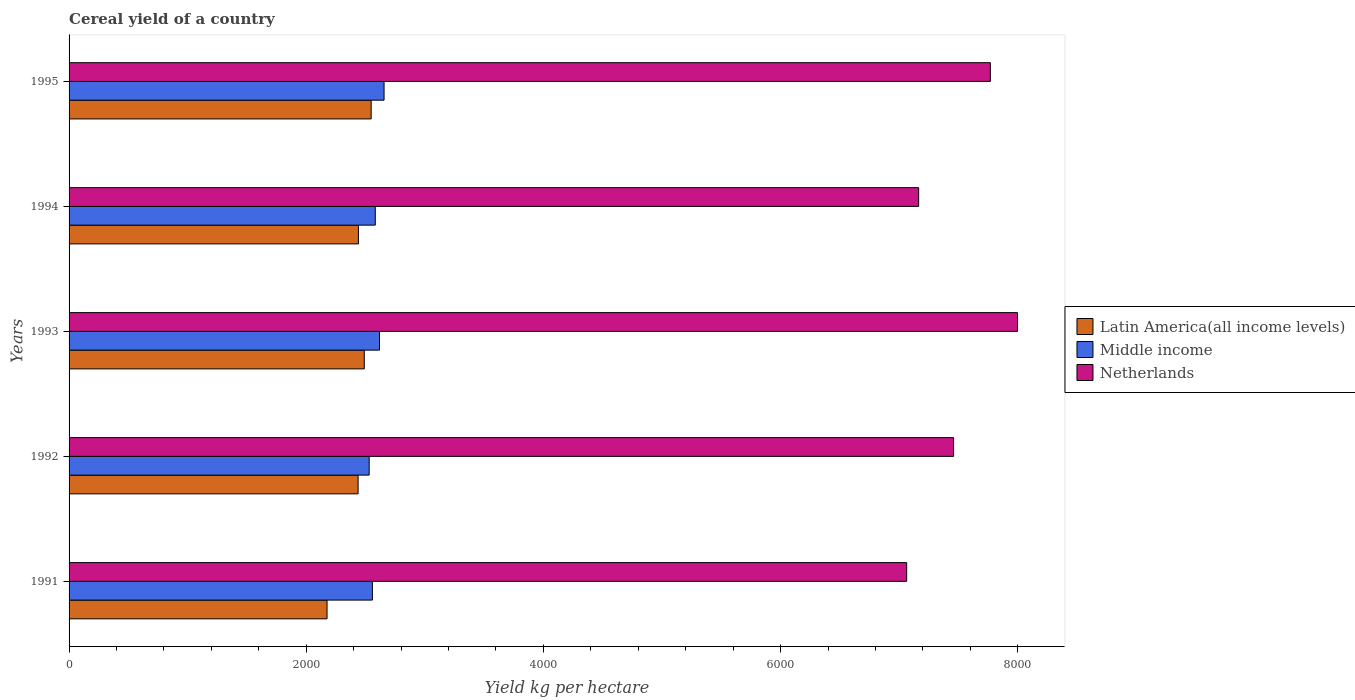How many different coloured bars are there?
Your answer should be compact. 3. How many groups of bars are there?
Offer a terse response. 5. Are the number of bars per tick equal to the number of legend labels?
Give a very brief answer. Yes. Are the number of bars on each tick of the Y-axis equal?
Keep it short and to the point. Yes. What is the total cereal yield in Middle income in 1995?
Provide a succinct answer. 2656.31. Across all years, what is the maximum total cereal yield in Middle income?
Ensure brevity in your answer.  2656.31. Across all years, what is the minimum total cereal yield in Latin America(all income levels)?
Your answer should be very brief. 2175.5. In which year was the total cereal yield in Netherlands maximum?
Offer a very short reply. 1993. What is the total total cereal yield in Latin America(all income levels) in the graph?
Give a very brief answer. 1.21e+04. What is the difference between the total cereal yield in Latin America(all income levels) in 1992 and that in 1994?
Offer a terse response. -2.81. What is the difference between the total cereal yield in Middle income in 1994 and the total cereal yield in Netherlands in 1991?
Make the answer very short. -4481.18. What is the average total cereal yield in Middle income per year?
Provide a succinct answer. 2588.96. In the year 1995, what is the difference between the total cereal yield in Netherlands and total cereal yield in Latin America(all income levels)?
Offer a terse response. 5221.77. What is the ratio of the total cereal yield in Middle income in 1991 to that in 1992?
Your answer should be compact. 1.01. Is the difference between the total cereal yield in Netherlands in 1994 and 1995 greater than the difference between the total cereal yield in Latin America(all income levels) in 1994 and 1995?
Ensure brevity in your answer.  No. What is the difference between the highest and the second highest total cereal yield in Latin America(all income levels)?
Give a very brief answer. 57.98. What is the difference between the highest and the lowest total cereal yield in Middle income?
Ensure brevity in your answer.  125.56. In how many years, is the total cereal yield in Middle income greater than the average total cereal yield in Middle income taken over all years?
Give a very brief answer. 2. What does the 3rd bar from the top in 1993 represents?
Offer a terse response. Latin America(all income levels). What does the 1st bar from the bottom in 1992 represents?
Your response must be concise. Latin America(all income levels). How many bars are there?
Your answer should be compact. 15. Are the values on the major ticks of X-axis written in scientific E-notation?
Ensure brevity in your answer.  No. How many legend labels are there?
Your answer should be compact. 3. How are the legend labels stacked?
Make the answer very short. Vertical. What is the title of the graph?
Give a very brief answer. Cereal yield of a country. Does "French Polynesia" appear as one of the legend labels in the graph?
Provide a short and direct response. No. What is the label or title of the X-axis?
Offer a terse response. Yield kg per hectare. What is the label or title of the Y-axis?
Your response must be concise. Years. What is the Yield kg per hectare in Latin America(all income levels) in 1991?
Offer a terse response. 2175.5. What is the Yield kg per hectare of Middle income in 1991?
Provide a short and direct response. 2557.74. What is the Yield kg per hectare in Netherlands in 1991?
Offer a very short reply. 7063.39. What is the Yield kg per hectare of Latin America(all income levels) in 1992?
Provide a succinct answer. 2437.3. What is the Yield kg per hectare in Middle income in 1992?
Make the answer very short. 2530.75. What is the Yield kg per hectare of Netherlands in 1992?
Keep it short and to the point. 7459.23. What is the Yield kg per hectare in Latin America(all income levels) in 1993?
Give a very brief answer. 2489.49. What is the Yield kg per hectare of Middle income in 1993?
Your answer should be very brief. 2617.8. What is the Yield kg per hectare of Netherlands in 1993?
Provide a short and direct response. 7998.36. What is the Yield kg per hectare of Latin America(all income levels) in 1994?
Offer a terse response. 2440.11. What is the Yield kg per hectare of Middle income in 1994?
Ensure brevity in your answer.  2582.21. What is the Yield kg per hectare of Netherlands in 1994?
Make the answer very short. 7164.46. What is the Yield kg per hectare in Latin America(all income levels) in 1995?
Offer a very short reply. 2547.46. What is the Yield kg per hectare in Middle income in 1995?
Offer a very short reply. 2656.31. What is the Yield kg per hectare of Netherlands in 1995?
Ensure brevity in your answer.  7769.23. Across all years, what is the maximum Yield kg per hectare in Latin America(all income levels)?
Offer a terse response. 2547.46. Across all years, what is the maximum Yield kg per hectare of Middle income?
Offer a very short reply. 2656.31. Across all years, what is the maximum Yield kg per hectare of Netherlands?
Offer a very short reply. 7998.36. Across all years, what is the minimum Yield kg per hectare in Latin America(all income levels)?
Offer a terse response. 2175.5. Across all years, what is the minimum Yield kg per hectare in Middle income?
Keep it short and to the point. 2530.75. Across all years, what is the minimum Yield kg per hectare in Netherlands?
Your answer should be very brief. 7063.39. What is the total Yield kg per hectare of Latin America(all income levels) in the graph?
Your answer should be very brief. 1.21e+04. What is the total Yield kg per hectare of Middle income in the graph?
Offer a terse response. 1.29e+04. What is the total Yield kg per hectare in Netherlands in the graph?
Keep it short and to the point. 3.75e+04. What is the difference between the Yield kg per hectare in Latin America(all income levels) in 1991 and that in 1992?
Your answer should be very brief. -261.8. What is the difference between the Yield kg per hectare in Middle income in 1991 and that in 1992?
Your response must be concise. 26.99. What is the difference between the Yield kg per hectare in Netherlands in 1991 and that in 1992?
Offer a terse response. -395.84. What is the difference between the Yield kg per hectare of Latin America(all income levels) in 1991 and that in 1993?
Your answer should be compact. -313.99. What is the difference between the Yield kg per hectare of Middle income in 1991 and that in 1993?
Give a very brief answer. -60.06. What is the difference between the Yield kg per hectare in Netherlands in 1991 and that in 1993?
Provide a short and direct response. -934.97. What is the difference between the Yield kg per hectare in Latin America(all income levels) in 1991 and that in 1994?
Your answer should be compact. -264.61. What is the difference between the Yield kg per hectare in Middle income in 1991 and that in 1994?
Your answer should be very brief. -24.46. What is the difference between the Yield kg per hectare in Netherlands in 1991 and that in 1994?
Keep it short and to the point. -101.07. What is the difference between the Yield kg per hectare in Latin America(all income levels) in 1991 and that in 1995?
Ensure brevity in your answer.  -371.96. What is the difference between the Yield kg per hectare of Middle income in 1991 and that in 1995?
Your answer should be very brief. -98.57. What is the difference between the Yield kg per hectare in Netherlands in 1991 and that in 1995?
Your answer should be compact. -705.84. What is the difference between the Yield kg per hectare in Latin America(all income levels) in 1992 and that in 1993?
Offer a terse response. -52.19. What is the difference between the Yield kg per hectare of Middle income in 1992 and that in 1993?
Give a very brief answer. -87.05. What is the difference between the Yield kg per hectare of Netherlands in 1992 and that in 1993?
Your answer should be very brief. -539.13. What is the difference between the Yield kg per hectare in Latin America(all income levels) in 1992 and that in 1994?
Offer a terse response. -2.81. What is the difference between the Yield kg per hectare of Middle income in 1992 and that in 1994?
Make the answer very short. -51.45. What is the difference between the Yield kg per hectare of Netherlands in 1992 and that in 1994?
Your response must be concise. 294.77. What is the difference between the Yield kg per hectare of Latin America(all income levels) in 1992 and that in 1995?
Your response must be concise. -110.16. What is the difference between the Yield kg per hectare of Middle income in 1992 and that in 1995?
Your answer should be compact. -125.56. What is the difference between the Yield kg per hectare in Netherlands in 1992 and that in 1995?
Offer a terse response. -310. What is the difference between the Yield kg per hectare of Latin America(all income levels) in 1993 and that in 1994?
Give a very brief answer. 49.37. What is the difference between the Yield kg per hectare of Middle income in 1993 and that in 1994?
Your answer should be compact. 35.6. What is the difference between the Yield kg per hectare in Netherlands in 1993 and that in 1994?
Ensure brevity in your answer.  833.9. What is the difference between the Yield kg per hectare in Latin America(all income levels) in 1993 and that in 1995?
Ensure brevity in your answer.  -57.98. What is the difference between the Yield kg per hectare of Middle income in 1993 and that in 1995?
Offer a terse response. -38.51. What is the difference between the Yield kg per hectare in Netherlands in 1993 and that in 1995?
Your answer should be compact. 229.13. What is the difference between the Yield kg per hectare of Latin America(all income levels) in 1994 and that in 1995?
Offer a very short reply. -107.35. What is the difference between the Yield kg per hectare in Middle income in 1994 and that in 1995?
Keep it short and to the point. -74.11. What is the difference between the Yield kg per hectare in Netherlands in 1994 and that in 1995?
Your answer should be compact. -604.77. What is the difference between the Yield kg per hectare of Latin America(all income levels) in 1991 and the Yield kg per hectare of Middle income in 1992?
Ensure brevity in your answer.  -355.25. What is the difference between the Yield kg per hectare of Latin America(all income levels) in 1991 and the Yield kg per hectare of Netherlands in 1992?
Your answer should be very brief. -5283.73. What is the difference between the Yield kg per hectare of Middle income in 1991 and the Yield kg per hectare of Netherlands in 1992?
Keep it short and to the point. -4901.48. What is the difference between the Yield kg per hectare in Latin America(all income levels) in 1991 and the Yield kg per hectare in Middle income in 1993?
Your answer should be compact. -442.3. What is the difference between the Yield kg per hectare in Latin America(all income levels) in 1991 and the Yield kg per hectare in Netherlands in 1993?
Offer a terse response. -5822.86. What is the difference between the Yield kg per hectare of Middle income in 1991 and the Yield kg per hectare of Netherlands in 1993?
Make the answer very short. -5440.62. What is the difference between the Yield kg per hectare in Latin America(all income levels) in 1991 and the Yield kg per hectare in Middle income in 1994?
Offer a very short reply. -406.7. What is the difference between the Yield kg per hectare in Latin America(all income levels) in 1991 and the Yield kg per hectare in Netherlands in 1994?
Provide a short and direct response. -4988.96. What is the difference between the Yield kg per hectare in Middle income in 1991 and the Yield kg per hectare in Netherlands in 1994?
Your response must be concise. -4606.72. What is the difference between the Yield kg per hectare in Latin America(all income levels) in 1991 and the Yield kg per hectare in Middle income in 1995?
Your answer should be compact. -480.81. What is the difference between the Yield kg per hectare in Latin America(all income levels) in 1991 and the Yield kg per hectare in Netherlands in 1995?
Offer a very short reply. -5593.73. What is the difference between the Yield kg per hectare in Middle income in 1991 and the Yield kg per hectare in Netherlands in 1995?
Keep it short and to the point. -5211.49. What is the difference between the Yield kg per hectare of Latin America(all income levels) in 1992 and the Yield kg per hectare of Middle income in 1993?
Give a very brief answer. -180.5. What is the difference between the Yield kg per hectare of Latin America(all income levels) in 1992 and the Yield kg per hectare of Netherlands in 1993?
Keep it short and to the point. -5561.06. What is the difference between the Yield kg per hectare of Middle income in 1992 and the Yield kg per hectare of Netherlands in 1993?
Your response must be concise. -5467.61. What is the difference between the Yield kg per hectare in Latin America(all income levels) in 1992 and the Yield kg per hectare in Middle income in 1994?
Your answer should be very brief. -144.9. What is the difference between the Yield kg per hectare of Latin America(all income levels) in 1992 and the Yield kg per hectare of Netherlands in 1994?
Make the answer very short. -4727.16. What is the difference between the Yield kg per hectare of Middle income in 1992 and the Yield kg per hectare of Netherlands in 1994?
Offer a terse response. -4633.71. What is the difference between the Yield kg per hectare of Latin America(all income levels) in 1992 and the Yield kg per hectare of Middle income in 1995?
Provide a succinct answer. -219.01. What is the difference between the Yield kg per hectare of Latin America(all income levels) in 1992 and the Yield kg per hectare of Netherlands in 1995?
Ensure brevity in your answer.  -5331.93. What is the difference between the Yield kg per hectare in Middle income in 1992 and the Yield kg per hectare in Netherlands in 1995?
Provide a succinct answer. -5238.48. What is the difference between the Yield kg per hectare in Latin America(all income levels) in 1993 and the Yield kg per hectare in Middle income in 1994?
Offer a terse response. -92.72. What is the difference between the Yield kg per hectare in Latin America(all income levels) in 1993 and the Yield kg per hectare in Netherlands in 1994?
Keep it short and to the point. -4674.98. What is the difference between the Yield kg per hectare of Middle income in 1993 and the Yield kg per hectare of Netherlands in 1994?
Offer a very short reply. -4546.66. What is the difference between the Yield kg per hectare of Latin America(all income levels) in 1993 and the Yield kg per hectare of Middle income in 1995?
Offer a terse response. -166.83. What is the difference between the Yield kg per hectare of Latin America(all income levels) in 1993 and the Yield kg per hectare of Netherlands in 1995?
Offer a terse response. -5279.74. What is the difference between the Yield kg per hectare of Middle income in 1993 and the Yield kg per hectare of Netherlands in 1995?
Give a very brief answer. -5151.43. What is the difference between the Yield kg per hectare in Latin America(all income levels) in 1994 and the Yield kg per hectare in Middle income in 1995?
Provide a succinct answer. -216.2. What is the difference between the Yield kg per hectare in Latin America(all income levels) in 1994 and the Yield kg per hectare in Netherlands in 1995?
Give a very brief answer. -5329.12. What is the difference between the Yield kg per hectare of Middle income in 1994 and the Yield kg per hectare of Netherlands in 1995?
Give a very brief answer. -5187.03. What is the average Yield kg per hectare in Latin America(all income levels) per year?
Give a very brief answer. 2417.97. What is the average Yield kg per hectare in Middle income per year?
Provide a succinct answer. 2588.96. What is the average Yield kg per hectare in Netherlands per year?
Your answer should be compact. 7490.94. In the year 1991, what is the difference between the Yield kg per hectare of Latin America(all income levels) and Yield kg per hectare of Middle income?
Offer a very short reply. -382.24. In the year 1991, what is the difference between the Yield kg per hectare of Latin America(all income levels) and Yield kg per hectare of Netherlands?
Your answer should be very brief. -4887.89. In the year 1991, what is the difference between the Yield kg per hectare in Middle income and Yield kg per hectare in Netherlands?
Provide a short and direct response. -4505.65. In the year 1992, what is the difference between the Yield kg per hectare of Latin America(all income levels) and Yield kg per hectare of Middle income?
Provide a succinct answer. -93.45. In the year 1992, what is the difference between the Yield kg per hectare in Latin America(all income levels) and Yield kg per hectare in Netherlands?
Provide a succinct answer. -5021.93. In the year 1992, what is the difference between the Yield kg per hectare of Middle income and Yield kg per hectare of Netherlands?
Your answer should be very brief. -4928.48. In the year 1993, what is the difference between the Yield kg per hectare in Latin America(all income levels) and Yield kg per hectare in Middle income?
Offer a very short reply. -128.32. In the year 1993, what is the difference between the Yield kg per hectare of Latin America(all income levels) and Yield kg per hectare of Netherlands?
Offer a terse response. -5508.88. In the year 1993, what is the difference between the Yield kg per hectare in Middle income and Yield kg per hectare in Netherlands?
Offer a very short reply. -5380.56. In the year 1994, what is the difference between the Yield kg per hectare in Latin America(all income levels) and Yield kg per hectare in Middle income?
Give a very brief answer. -142.09. In the year 1994, what is the difference between the Yield kg per hectare of Latin America(all income levels) and Yield kg per hectare of Netherlands?
Offer a terse response. -4724.35. In the year 1994, what is the difference between the Yield kg per hectare of Middle income and Yield kg per hectare of Netherlands?
Give a very brief answer. -4582.26. In the year 1995, what is the difference between the Yield kg per hectare in Latin America(all income levels) and Yield kg per hectare in Middle income?
Offer a terse response. -108.85. In the year 1995, what is the difference between the Yield kg per hectare in Latin America(all income levels) and Yield kg per hectare in Netherlands?
Your response must be concise. -5221.77. In the year 1995, what is the difference between the Yield kg per hectare of Middle income and Yield kg per hectare of Netherlands?
Offer a terse response. -5112.92. What is the ratio of the Yield kg per hectare of Latin America(all income levels) in 1991 to that in 1992?
Offer a terse response. 0.89. What is the ratio of the Yield kg per hectare in Middle income in 1991 to that in 1992?
Your answer should be very brief. 1.01. What is the ratio of the Yield kg per hectare in Netherlands in 1991 to that in 1992?
Offer a terse response. 0.95. What is the ratio of the Yield kg per hectare of Latin America(all income levels) in 1991 to that in 1993?
Provide a short and direct response. 0.87. What is the ratio of the Yield kg per hectare of Middle income in 1991 to that in 1993?
Offer a very short reply. 0.98. What is the ratio of the Yield kg per hectare in Netherlands in 1991 to that in 1993?
Ensure brevity in your answer.  0.88. What is the ratio of the Yield kg per hectare in Latin America(all income levels) in 1991 to that in 1994?
Provide a succinct answer. 0.89. What is the ratio of the Yield kg per hectare in Middle income in 1991 to that in 1994?
Give a very brief answer. 0.99. What is the ratio of the Yield kg per hectare of Netherlands in 1991 to that in 1994?
Keep it short and to the point. 0.99. What is the ratio of the Yield kg per hectare of Latin America(all income levels) in 1991 to that in 1995?
Provide a succinct answer. 0.85. What is the ratio of the Yield kg per hectare of Middle income in 1991 to that in 1995?
Make the answer very short. 0.96. What is the ratio of the Yield kg per hectare of Latin America(all income levels) in 1992 to that in 1993?
Provide a short and direct response. 0.98. What is the ratio of the Yield kg per hectare of Middle income in 1992 to that in 1993?
Make the answer very short. 0.97. What is the ratio of the Yield kg per hectare in Netherlands in 1992 to that in 1993?
Keep it short and to the point. 0.93. What is the ratio of the Yield kg per hectare in Middle income in 1992 to that in 1994?
Your answer should be very brief. 0.98. What is the ratio of the Yield kg per hectare of Netherlands in 1992 to that in 1994?
Give a very brief answer. 1.04. What is the ratio of the Yield kg per hectare of Latin America(all income levels) in 1992 to that in 1995?
Your response must be concise. 0.96. What is the ratio of the Yield kg per hectare in Middle income in 1992 to that in 1995?
Ensure brevity in your answer.  0.95. What is the ratio of the Yield kg per hectare of Netherlands in 1992 to that in 1995?
Make the answer very short. 0.96. What is the ratio of the Yield kg per hectare of Latin America(all income levels) in 1993 to that in 1994?
Keep it short and to the point. 1.02. What is the ratio of the Yield kg per hectare in Middle income in 1993 to that in 1994?
Offer a terse response. 1.01. What is the ratio of the Yield kg per hectare of Netherlands in 1993 to that in 1994?
Give a very brief answer. 1.12. What is the ratio of the Yield kg per hectare in Latin America(all income levels) in 1993 to that in 1995?
Your answer should be compact. 0.98. What is the ratio of the Yield kg per hectare in Middle income in 1993 to that in 1995?
Provide a short and direct response. 0.99. What is the ratio of the Yield kg per hectare in Netherlands in 1993 to that in 1995?
Provide a short and direct response. 1.03. What is the ratio of the Yield kg per hectare in Latin America(all income levels) in 1994 to that in 1995?
Offer a very short reply. 0.96. What is the ratio of the Yield kg per hectare of Middle income in 1994 to that in 1995?
Your response must be concise. 0.97. What is the ratio of the Yield kg per hectare of Netherlands in 1994 to that in 1995?
Your answer should be very brief. 0.92. What is the difference between the highest and the second highest Yield kg per hectare in Latin America(all income levels)?
Keep it short and to the point. 57.98. What is the difference between the highest and the second highest Yield kg per hectare of Middle income?
Provide a short and direct response. 38.51. What is the difference between the highest and the second highest Yield kg per hectare of Netherlands?
Your answer should be compact. 229.13. What is the difference between the highest and the lowest Yield kg per hectare of Latin America(all income levels)?
Your answer should be very brief. 371.96. What is the difference between the highest and the lowest Yield kg per hectare of Middle income?
Your response must be concise. 125.56. What is the difference between the highest and the lowest Yield kg per hectare of Netherlands?
Your response must be concise. 934.97. 